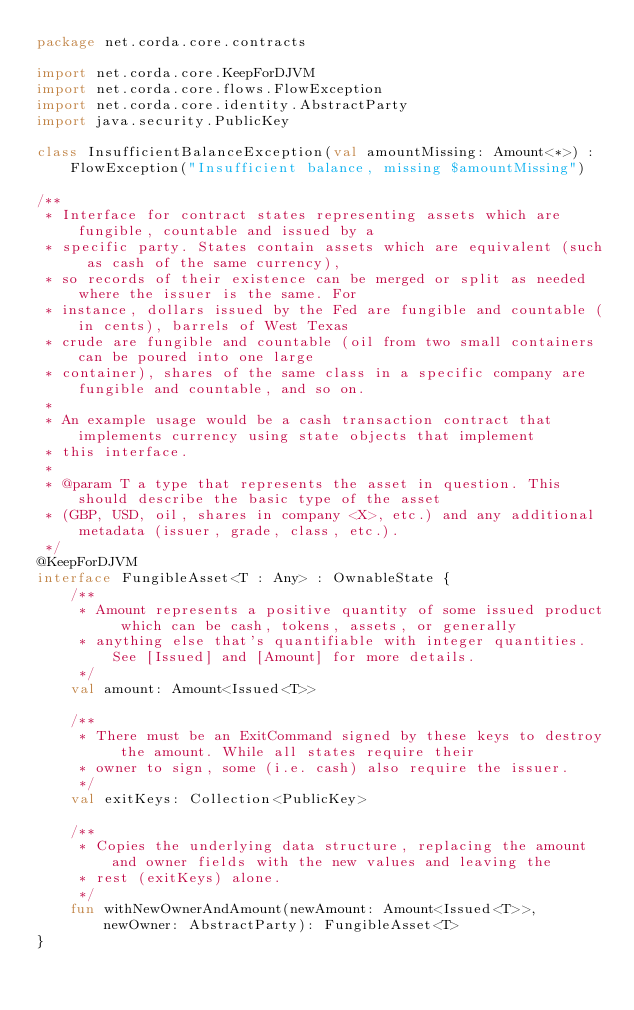Convert code to text. <code><loc_0><loc_0><loc_500><loc_500><_Kotlin_>package net.corda.core.contracts

import net.corda.core.KeepForDJVM
import net.corda.core.flows.FlowException
import net.corda.core.identity.AbstractParty
import java.security.PublicKey

class InsufficientBalanceException(val amountMissing: Amount<*>) : FlowException("Insufficient balance, missing $amountMissing")

/**
 * Interface for contract states representing assets which are fungible, countable and issued by a
 * specific party. States contain assets which are equivalent (such as cash of the same currency),
 * so records of their existence can be merged or split as needed where the issuer is the same. For
 * instance, dollars issued by the Fed are fungible and countable (in cents), barrels of West Texas
 * crude are fungible and countable (oil from two small containers can be poured into one large
 * container), shares of the same class in a specific company are fungible and countable, and so on.
 *
 * An example usage would be a cash transaction contract that implements currency using state objects that implement
 * this interface.
 *
 * @param T a type that represents the asset in question. This should describe the basic type of the asset
 * (GBP, USD, oil, shares in company <X>, etc.) and any additional metadata (issuer, grade, class, etc.).
 */
@KeepForDJVM
interface FungibleAsset<T : Any> : OwnableState {
    /**
     * Amount represents a positive quantity of some issued product which can be cash, tokens, assets, or generally
     * anything else that's quantifiable with integer quantities. See [Issued] and [Amount] for more details.
     */
    val amount: Amount<Issued<T>>

    /**
     * There must be an ExitCommand signed by these keys to destroy the amount. While all states require their
     * owner to sign, some (i.e. cash) also require the issuer.
     */
    val exitKeys: Collection<PublicKey>

    /**
     * Copies the underlying data structure, replacing the amount and owner fields with the new values and leaving the
     * rest (exitKeys) alone.
     */
    fun withNewOwnerAndAmount(newAmount: Amount<Issued<T>>, newOwner: AbstractParty): FungibleAsset<T>
}
</code> 